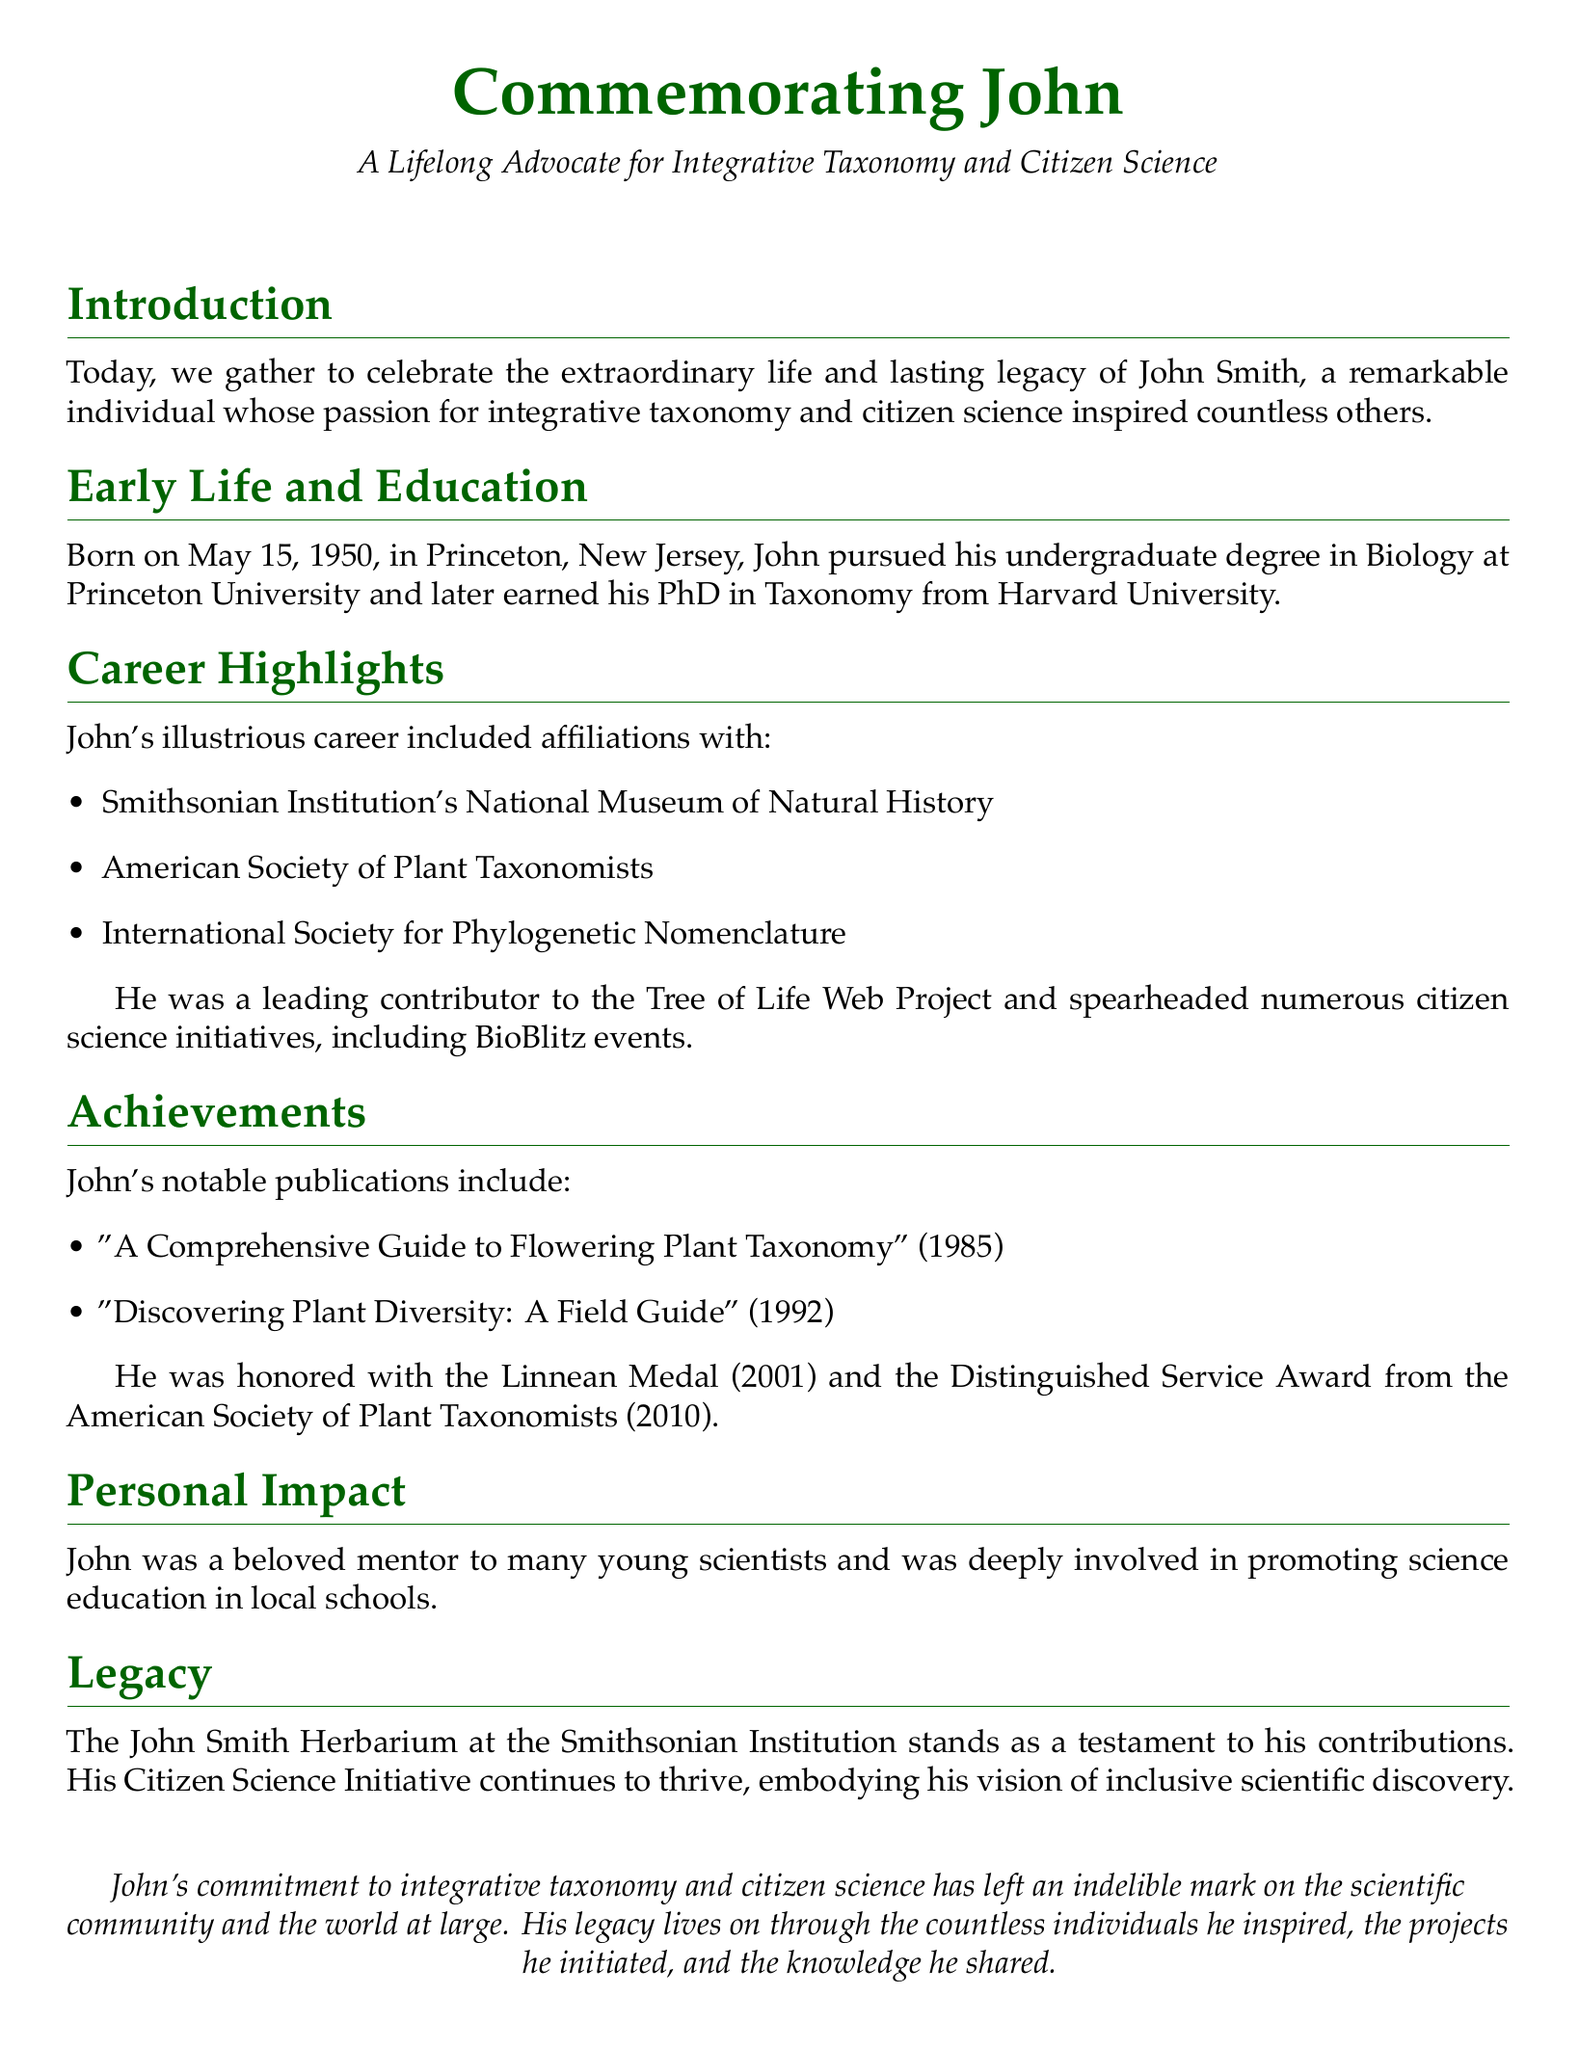What is John's full name? John is referred to as John Smith throughout the document.
Answer: John Smith When was John born? The document states that John was born on May 15, 1950.
Answer: May 15, 1950 What degree did John earn from Harvard University? The document mentions that John earned his PhD in Taxonomy from Harvard University.
Answer: PhD in Taxonomy Which prestigious medal did John receive in 2001? The document specifies that John was honored with the Linnean Medal in 2001.
Answer: Linnean Medal What initiative did John spearhead that involves community participation? The document highlights that John spearheaded numerous citizen science initiatives, including BioBlitz events.
Answer: BioBlitz events What is the name of the herbarium that commemorates John? The document states that the John Smith Herbarium at the Smithsonian Institution is named after him.
Answer: John Smith Herbarium Which publication by John was released in 1985? The document lists "A Comprehensive Guide to Flowering Plant Taxonomy" as a publication from 1985.
Answer: A Comprehensive Guide to Flowering Plant Taxonomy How did John contribute to the education of young scientists? The document mentions that John was a beloved mentor to many young scientists.
Answer: Beloved mentor What lasting impact did John's work have on science education? The document states that he was deeply involved in promoting science education in local schools.
Answer: Promoting science education 